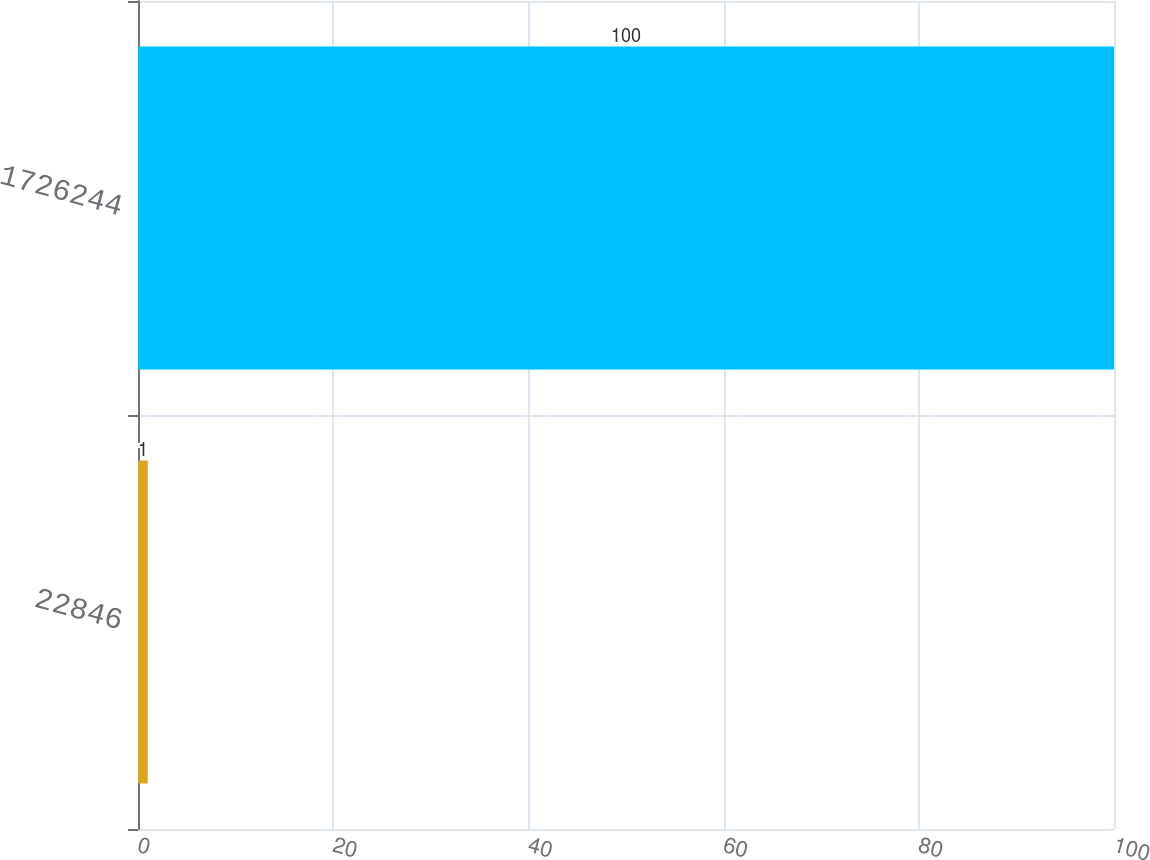<chart> <loc_0><loc_0><loc_500><loc_500><bar_chart><fcel>22846<fcel>1726244<nl><fcel>1<fcel>100<nl></chart> 